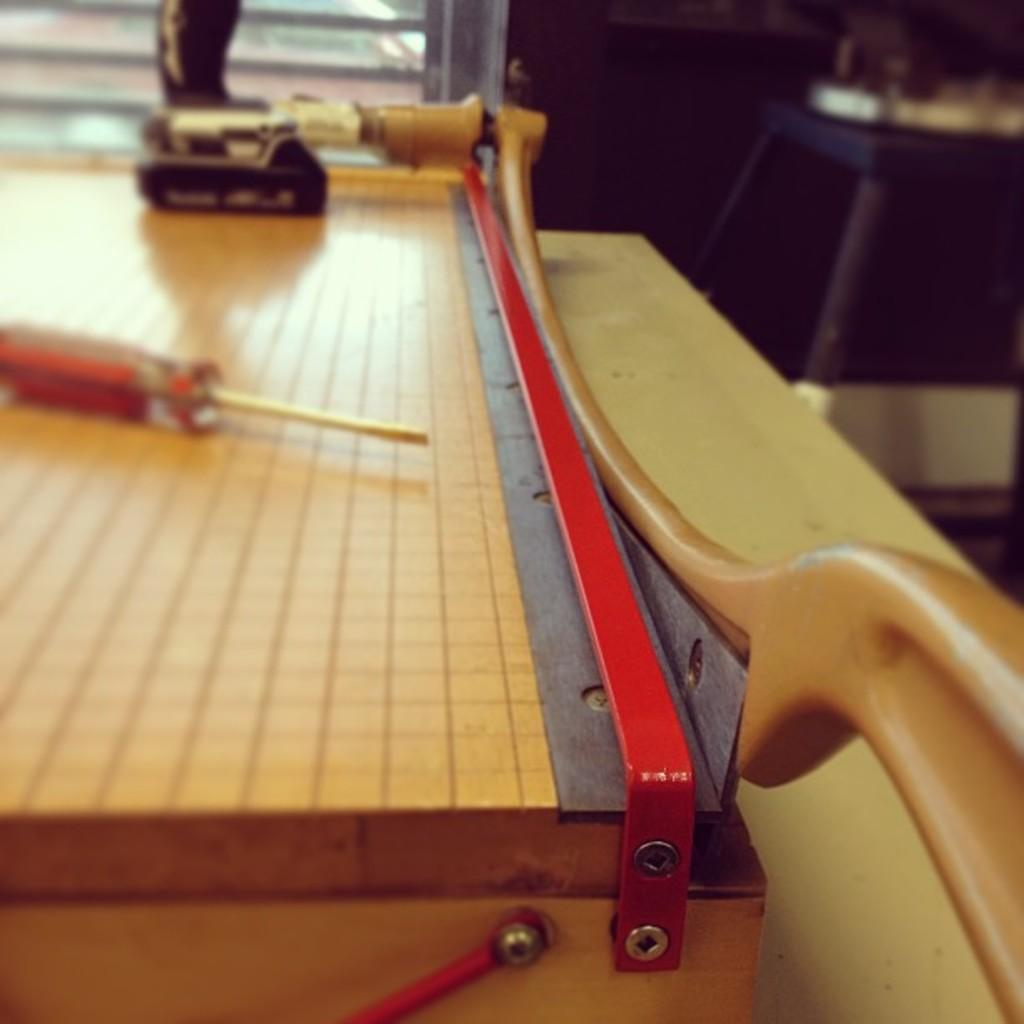What type of furniture is present in the image? There is a table in the image. What object can be seen on the left side of the table? There is a red screwdriver on the left side of the table. What type of ship is visible in the image? There is no ship present in the image; it only features a table and a red screwdriver. What is the desire of the screwdriver in the image? The screwdriver is an inanimate object and does not have desires. 